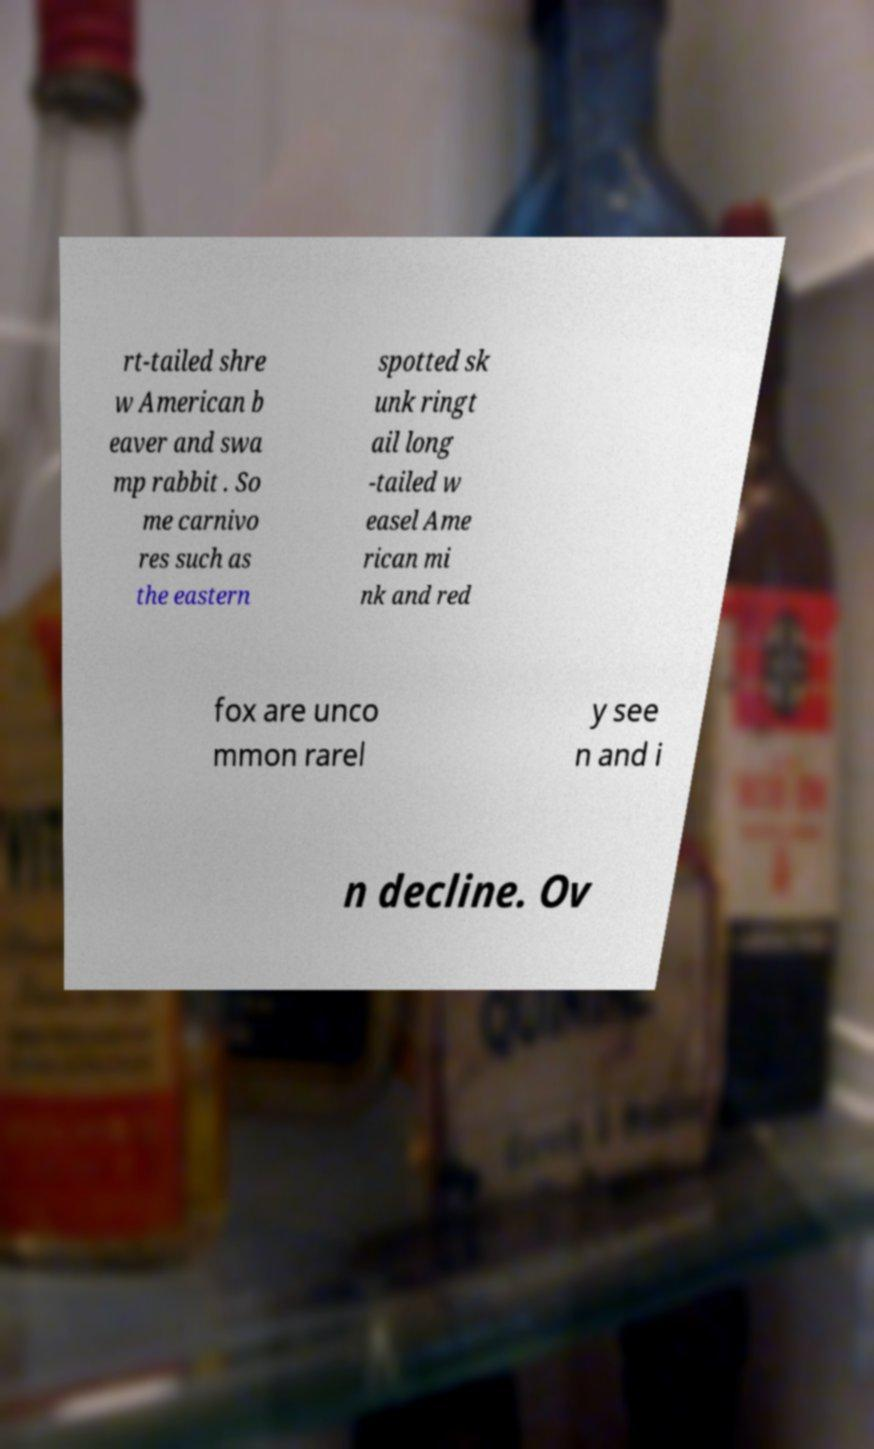There's text embedded in this image that I need extracted. Can you transcribe it verbatim? rt-tailed shre w American b eaver and swa mp rabbit . So me carnivo res such as the eastern spotted sk unk ringt ail long -tailed w easel Ame rican mi nk and red fox are unco mmon rarel y see n and i n decline. Ov 